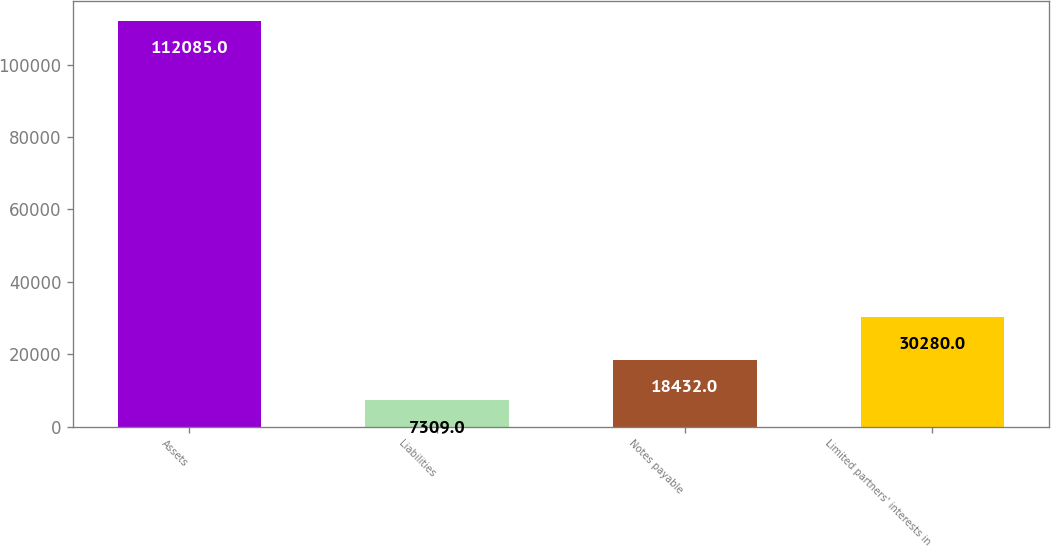Convert chart. <chart><loc_0><loc_0><loc_500><loc_500><bar_chart><fcel>Assets<fcel>Liabilities<fcel>Notes payable<fcel>Limited partners' interests in<nl><fcel>112085<fcel>7309<fcel>18432<fcel>30280<nl></chart> 